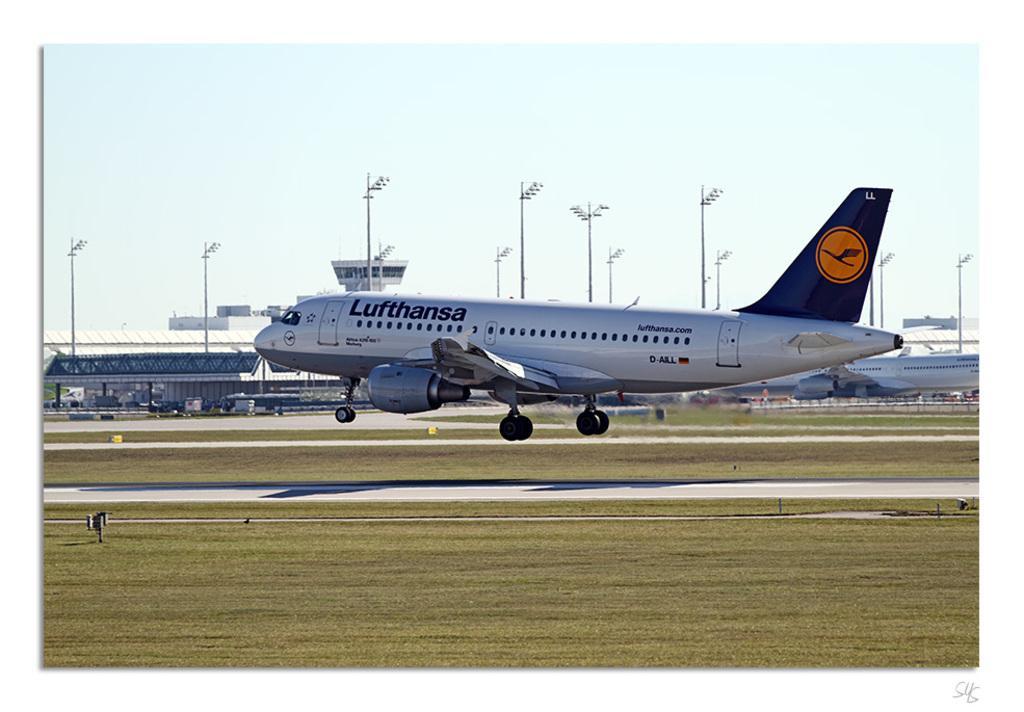Please provide a concise description of this image. In this picture I can see couple of aeroplanes and a building and few pole lights and grass on the both side of the runway and a cloudy sky. 